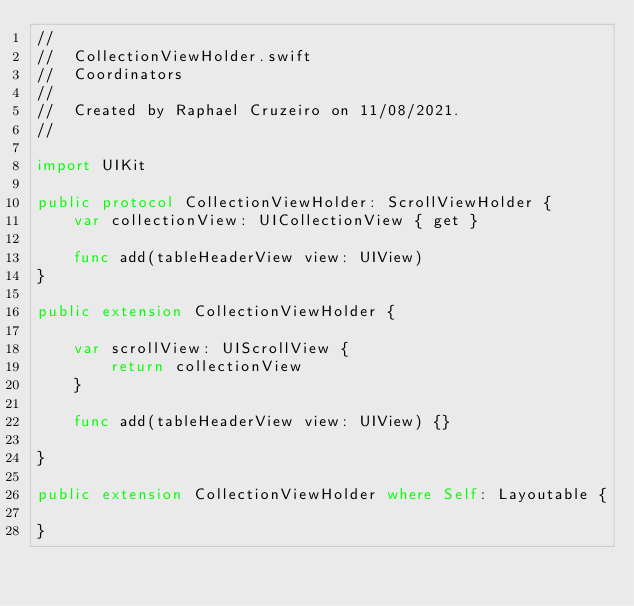Convert code to text. <code><loc_0><loc_0><loc_500><loc_500><_Swift_>//
//  CollectionViewHolder.swift
//  Coordinators
//
//  Created by Raphael Cruzeiro on 11/08/2021.
//

import UIKit

public protocol CollectionViewHolder: ScrollViewHolder {
    var collectionView: UICollectionView { get }
    
    func add(tableHeaderView view: UIView)
}

public extension CollectionViewHolder {
    
    var scrollView: UIScrollView {
        return collectionView
    }
    
    func add(tableHeaderView view: UIView) {}
    
}

public extension CollectionViewHolder where Self: Layoutable {
    
}
</code> 